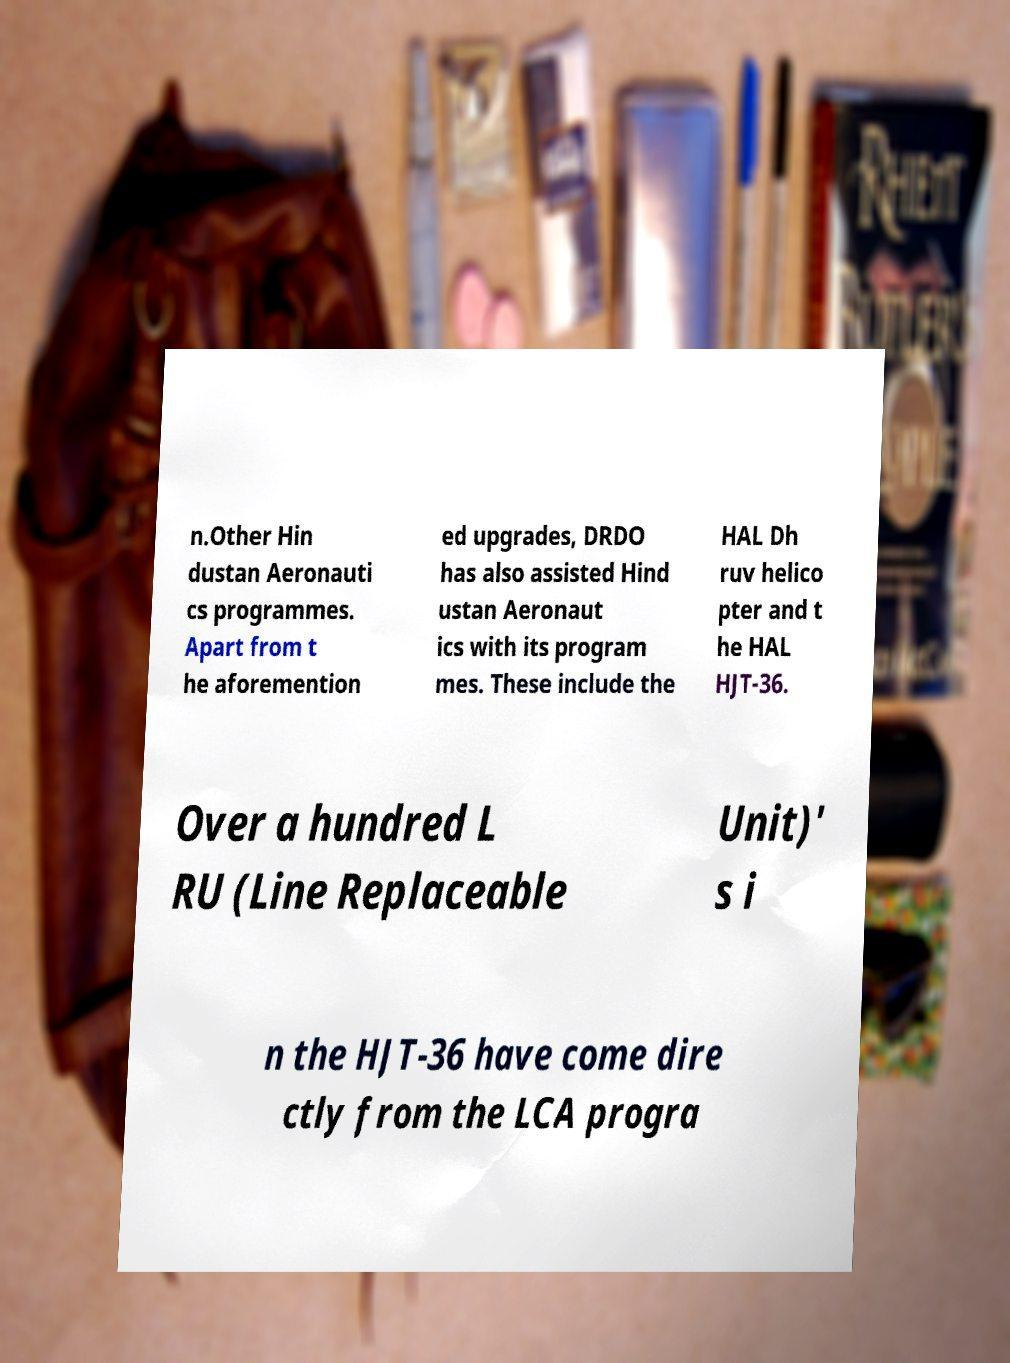There's text embedded in this image that I need extracted. Can you transcribe it verbatim? n.Other Hin dustan Aeronauti cs programmes. Apart from t he aforemention ed upgrades, DRDO has also assisted Hind ustan Aeronaut ics with its program mes. These include the HAL Dh ruv helico pter and t he HAL HJT-36. Over a hundred L RU (Line Replaceable Unit)' s i n the HJT-36 have come dire ctly from the LCA progra 